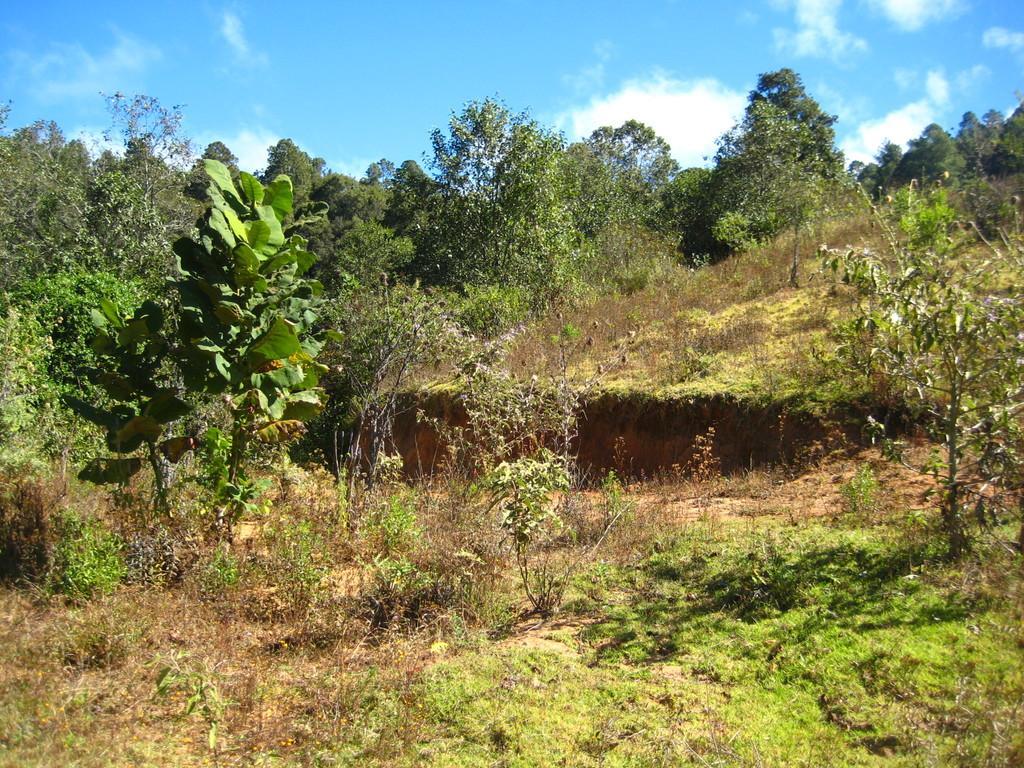Please provide a concise description of this image. In this picture we can see trees and in the background we can see the sky with clouds. 